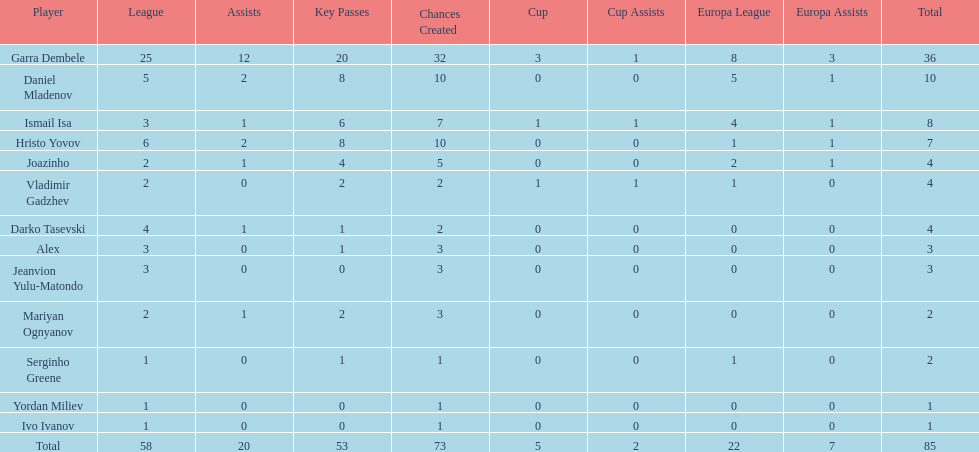Which participants hold at least 4 in the europa league? Garra Dembele, Daniel Mladenov, Ismail Isa. 